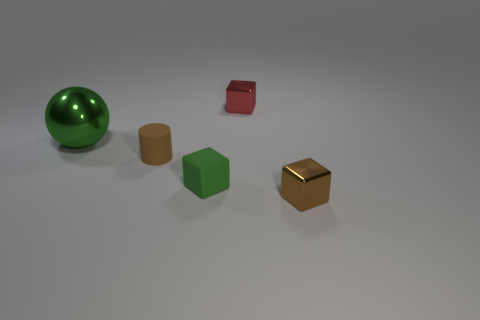Does the tiny matte cube have the same color as the big metallic ball?
Your answer should be compact. Yes. What color is the shiny cube that is left of the tiny metallic cube that is in front of the big green metal ball?
Your answer should be compact. Red. What number of tiny things are cyan spheres or green metal objects?
Provide a succinct answer. 0. There is a small thing that is behind the matte block and on the left side of the small red metallic object; what is its color?
Offer a terse response. Brown. Is the material of the green sphere the same as the small red block?
Offer a terse response. Yes. There is a large green metallic thing; what shape is it?
Your response must be concise. Sphere. How many brown objects are behind the tiny metal block in front of the small block that is behind the green rubber block?
Your response must be concise. 1. The other small metal object that is the same shape as the red object is what color?
Provide a short and direct response. Brown. There is a brown thing to the left of the brown object on the right side of the small thing that is behind the big metallic object; what shape is it?
Keep it short and to the point. Cylinder. There is a thing that is to the left of the tiny green rubber thing and to the right of the green shiny sphere; what size is it?
Offer a very short reply. Small. 